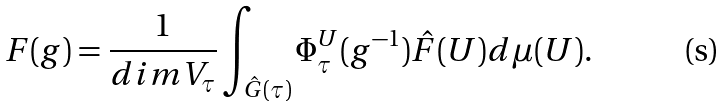Convert formula to latex. <formula><loc_0><loc_0><loc_500><loc_500>F ( g ) = \frac { 1 } { d i m V _ { \tau } } \int _ { \hat { G } ( \tau ) } \Phi _ { \tau } ^ { U } ( g ^ { - 1 } ) \hat { F } ( U ) d \mu ( U ) .</formula> 